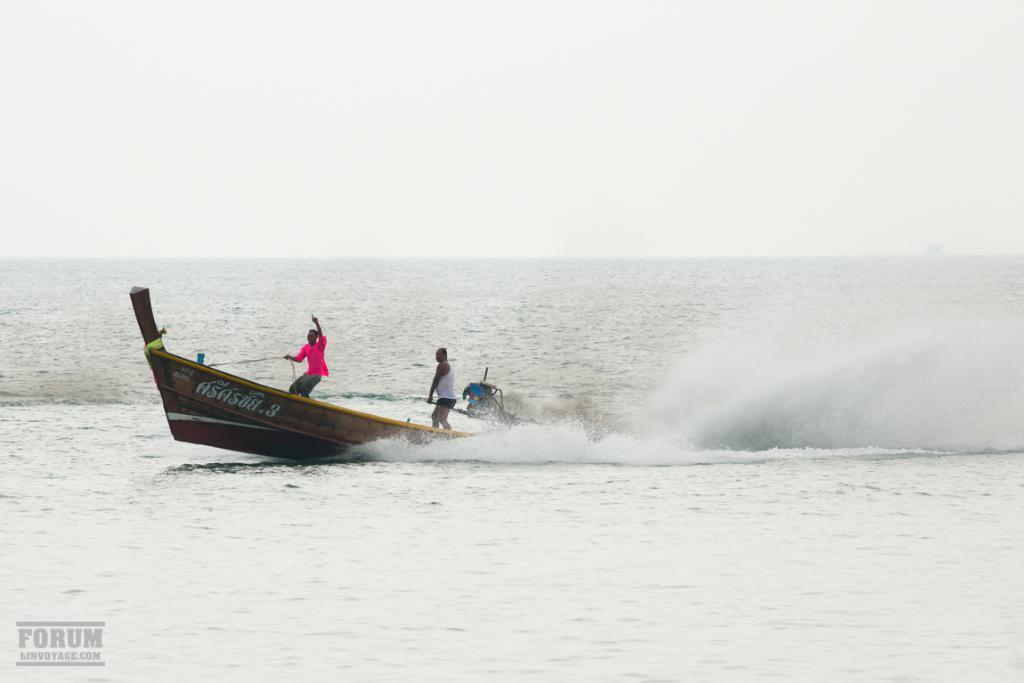How would you summarize this image in a sentence or two? In the picture I can see a person wearing pink color shirt and a person wearing a white dress is standing on the boat which is floating on the water. Here we can see a wave and in the background, we can see sky. Here we can see the watermark on the bottom left side of the image. 